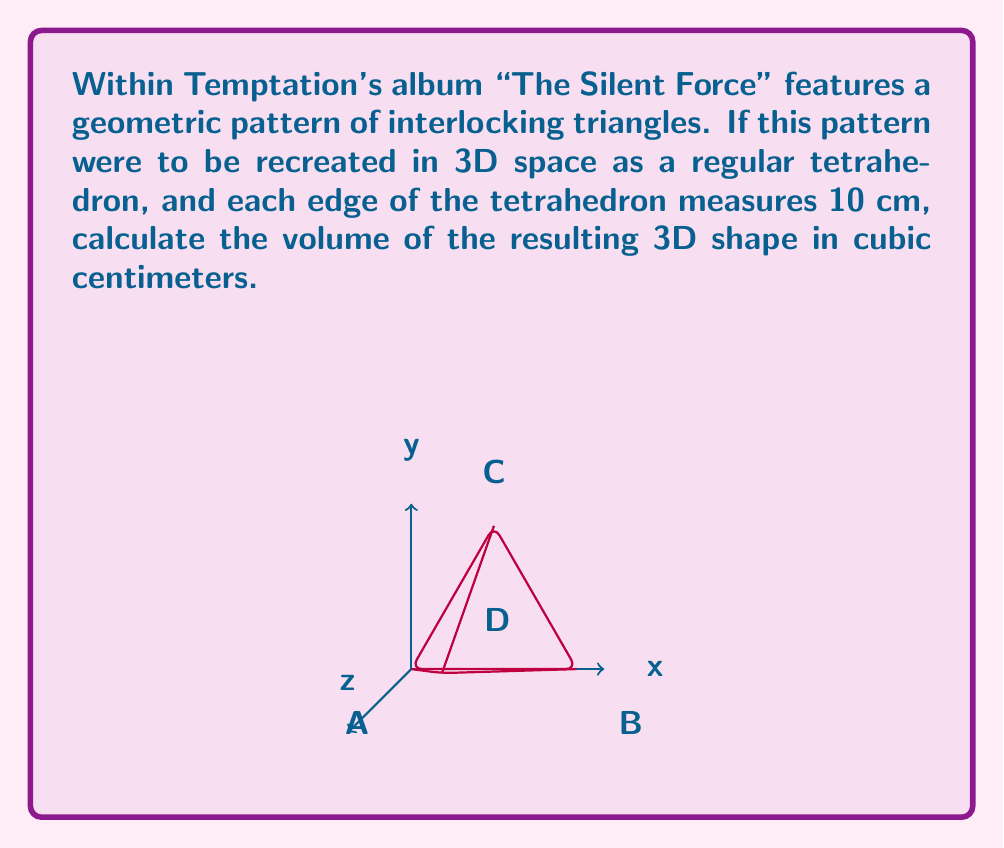Could you help me with this problem? To solve this problem, we'll follow these steps:

1) The volume of a regular tetrahedron is given by the formula:

   $$V = \frac{a^3}{6\sqrt{2}}$$

   where $a$ is the length of an edge.

2) We're given that each edge measures 10 cm, so $a = 10$.

3) Let's substitute this into our formula:

   $$V = \frac{10^3}{6\sqrt{2}}$$

4) Simplify the numerator:

   $$V = \frac{1000}{6\sqrt{2}}$$

5) Simplify further:

   $$V = \frac{500}{3\sqrt{2}}$$

6) To get a decimal approximation, we can use a calculator:

   $$V \approx 117.85$$

7) Rounding to two decimal places:

   $$V \approx 117.85 \text{ cm}^3$$

This volume represents the 3D space occupied by the geometric pattern from Within Temptation's album artwork when recreated as a regular tetrahedron.
Answer: $\frac{500}{3\sqrt{2}} \approx 117.85 \text{ cm}^3$ 